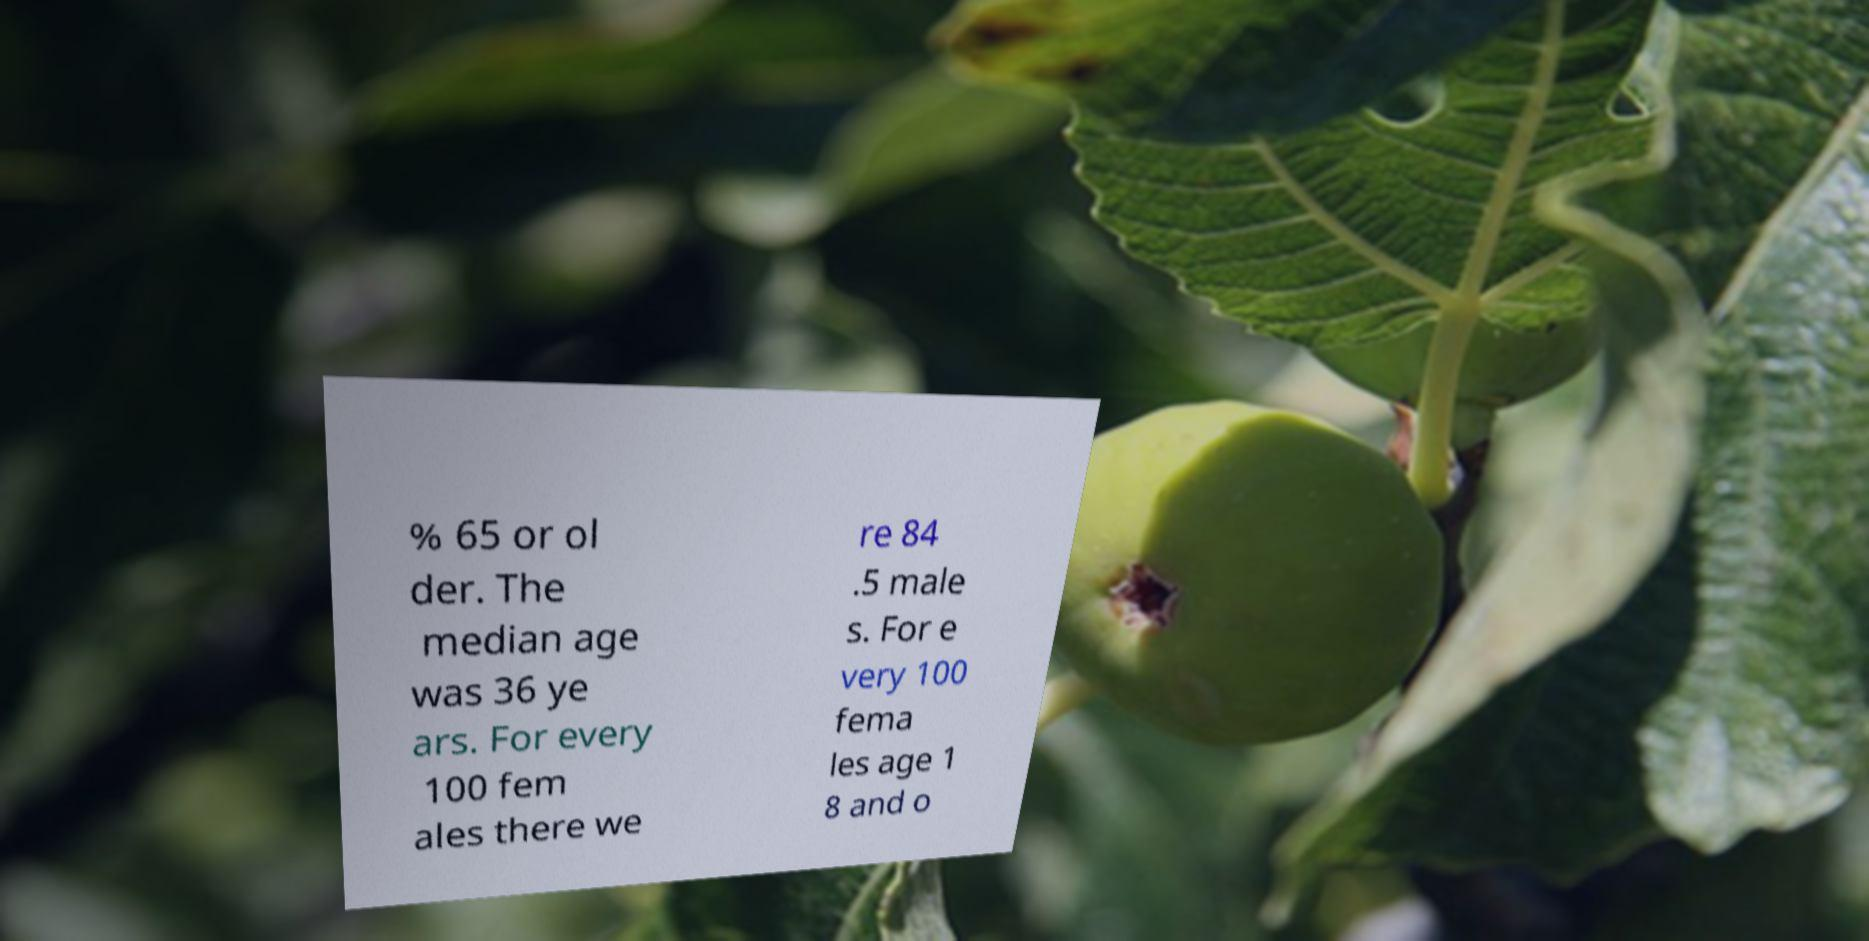Please identify and transcribe the text found in this image. % 65 or ol der. The median age was 36 ye ars. For every 100 fem ales there we re 84 .5 male s. For e very 100 fema les age 1 8 and o 